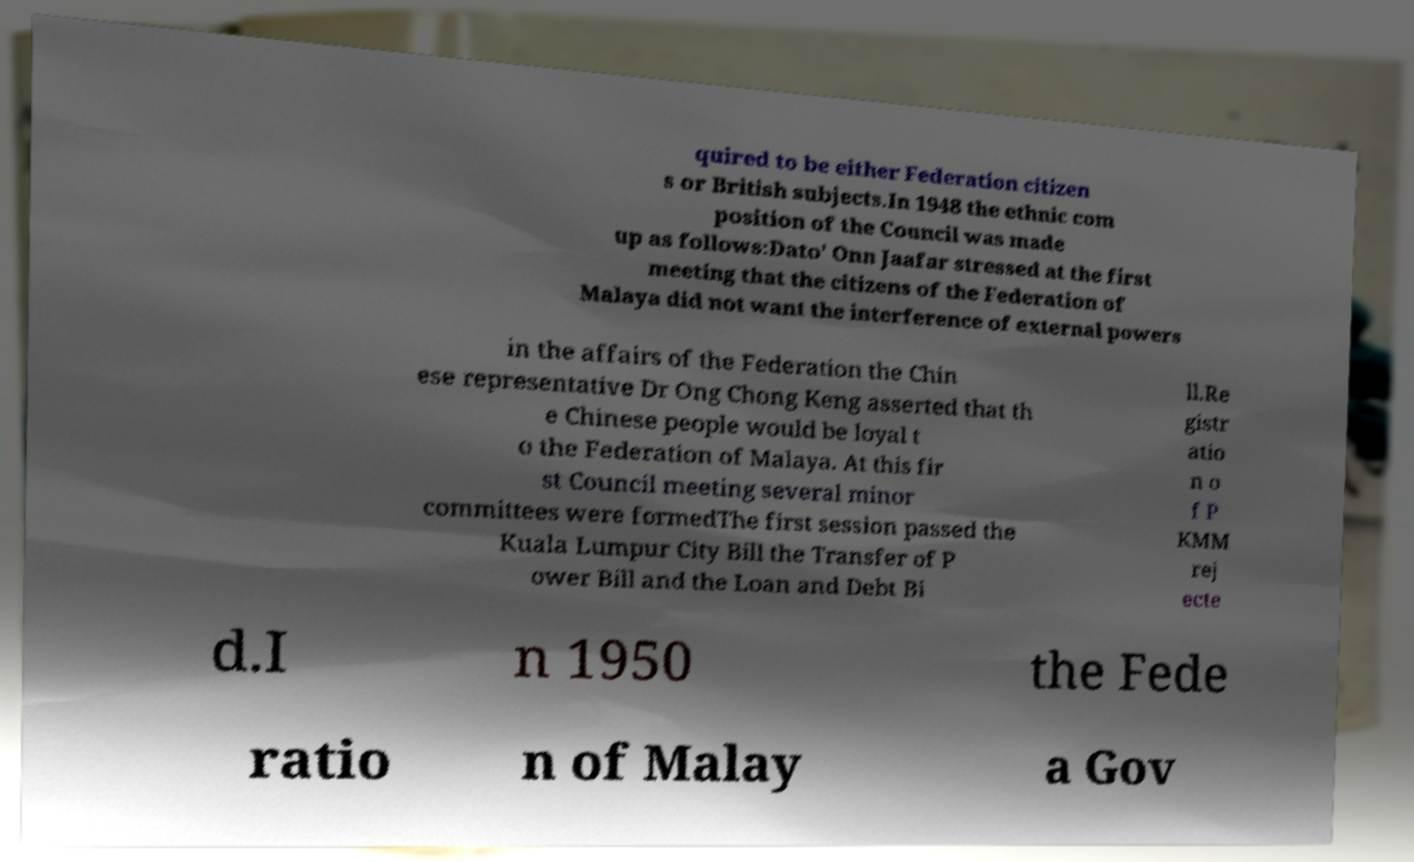Could you assist in decoding the text presented in this image and type it out clearly? quired to be either Federation citizen s or British subjects.In 1948 the ethnic com position of the Council was made up as follows:Dato' Onn Jaafar stressed at the first meeting that the citizens of the Federation of Malaya did not want the interference of external powers in the affairs of the Federation the Chin ese representative Dr Ong Chong Keng asserted that th e Chinese people would be loyal t o the Federation of Malaya. At this fir st Council meeting several minor committees were formedThe first session passed the Kuala Lumpur City Bill the Transfer of P ower Bill and the Loan and Debt Bi ll.Re gistr atio n o f P KMM rej ecte d.I n 1950 the Fede ratio n of Malay a Gov 